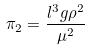<formula> <loc_0><loc_0><loc_500><loc_500>\pi _ { 2 } = \frac { l ^ { 3 } g \rho ^ { 2 } } { \mu ^ { 2 } }</formula> 